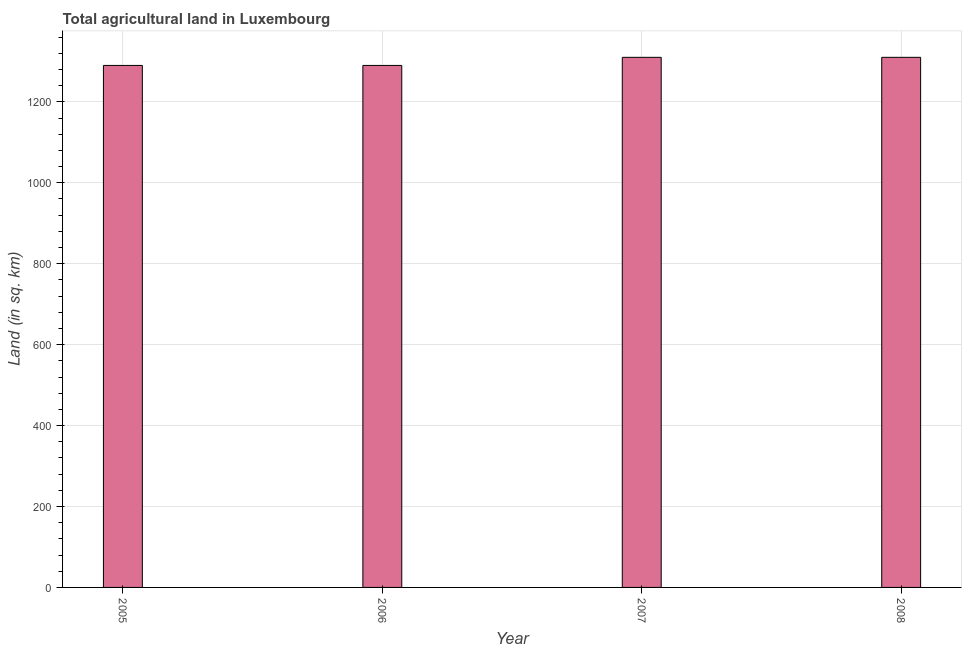Does the graph contain any zero values?
Make the answer very short. No. What is the title of the graph?
Provide a succinct answer. Total agricultural land in Luxembourg. What is the label or title of the Y-axis?
Make the answer very short. Land (in sq. km). What is the agricultural land in 2007?
Offer a terse response. 1310. Across all years, what is the maximum agricultural land?
Provide a short and direct response. 1310. Across all years, what is the minimum agricultural land?
Give a very brief answer. 1290. In which year was the agricultural land maximum?
Provide a short and direct response. 2007. What is the sum of the agricultural land?
Keep it short and to the point. 5200. What is the average agricultural land per year?
Your answer should be compact. 1300. What is the median agricultural land?
Your answer should be compact. 1300. In how many years, is the agricultural land greater than 880 sq. km?
Keep it short and to the point. 4. Do a majority of the years between 2006 and 2005 (inclusive) have agricultural land greater than 960 sq. km?
Keep it short and to the point. No. What is the ratio of the agricultural land in 2005 to that in 2007?
Ensure brevity in your answer.  0.98. Is the agricultural land in 2007 less than that in 2008?
Provide a short and direct response. No. Is the difference between the agricultural land in 2005 and 2006 greater than the difference between any two years?
Offer a very short reply. No. What is the difference between the highest and the second highest agricultural land?
Keep it short and to the point. 0. What is the difference between the highest and the lowest agricultural land?
Provide a succinct answer. 20. How many bars are there?
Provide a short and direct response. 4. Are all the bars in the graph horizontal?
Offer a very short reply. No. How many years are there in the graph?
Your response must be concise. 4. What is the difference between two consecutive major ticks on the Y-axis?
Provide a succinct answer. 200. What is the Land (in sq. km) of 2005?
Keep it short and to the point. 1290. What is the Land (in sq. km) in 2006?
Make the answer very short. 1290. What is the Land (in sq. km) in 2007?
Your response must be concise. 1310. What is the Land (in sq. km) of 2008?
Give a very brief answer. 1310. What is the difference between the Land (in sq. km) in 2005 and 2006?
Ensure brevity in your answer.  0. What is the difference between the Land (in sq. km) in 2005 and 2007?
Offer a terse response. -20. What is the difference between the Land (in sq. km) in 2006 and 2007?
Provide a succinct answer. -20. What is the difference between the Land (in sq. km) in 2007 and 2008?
Your answer should be very brief. 0. What is the ratio of the Land (in sq. km) in 2005 to that in 2006?
Your answer should be compact. 1. What is the ratio of the Land (in sq. km) in 2006 to that in 2007?
Offer a terse response. 0.98. What is the ratio of the Land (in sq. km) in 2006 to that in 2008?
Your answer should be compact. 0.98. 